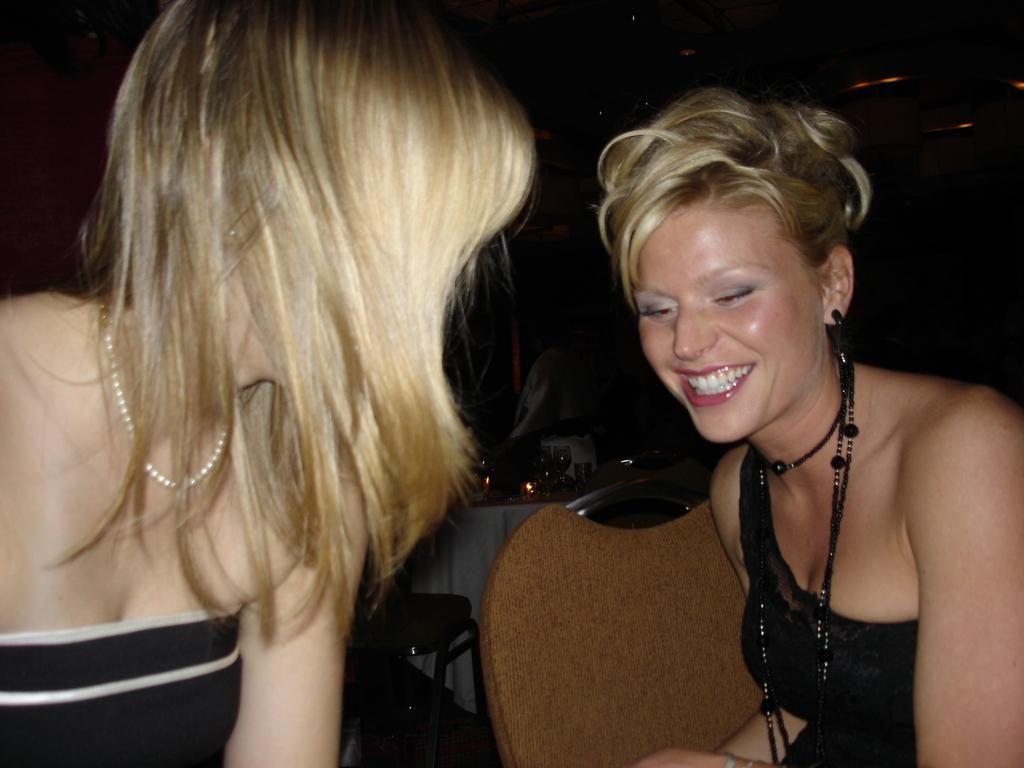How many women are in the image? There are two women in the image. What direction is the woman on the left facing? The woman on the left is facing towards the back. What type of furniture can be seen in the image? There are chairs in the image. What is the color of the background in the image? The background of the image is dark. What type of cap can be seen floating on the waves in the image? There are no waves or caps present in the image; it features two women and chairs in a dark background. 